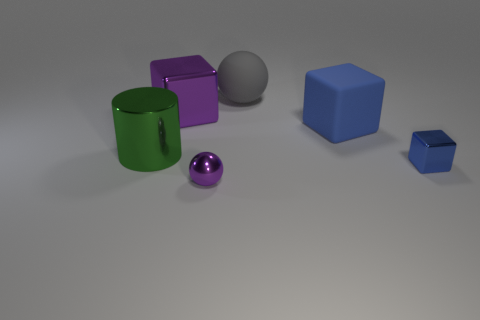Subtract all big metallic cubes. How many cubes are left? 2 Subtract all red balls. How many blue blocks are left? 2 Add 4 big purple blocks. How many objects exist? 10 Subtract 1 balls. How many balls are left? 1 Subtract all purple cubes. How many cubes are left? 2 Subtract all balls. How many objects are left? 4 Subtract 0 brown cylinders. How many objects are left? 6 Subtract all blue balls. Subtract all green cubes. How many balls are left? 2 Subtract all tiny brown shiny cylinders. Subtract all blocks. How many objects are left? 3 Add 2 tiny blue blocks. How many tiny blue blocks are left? 3 